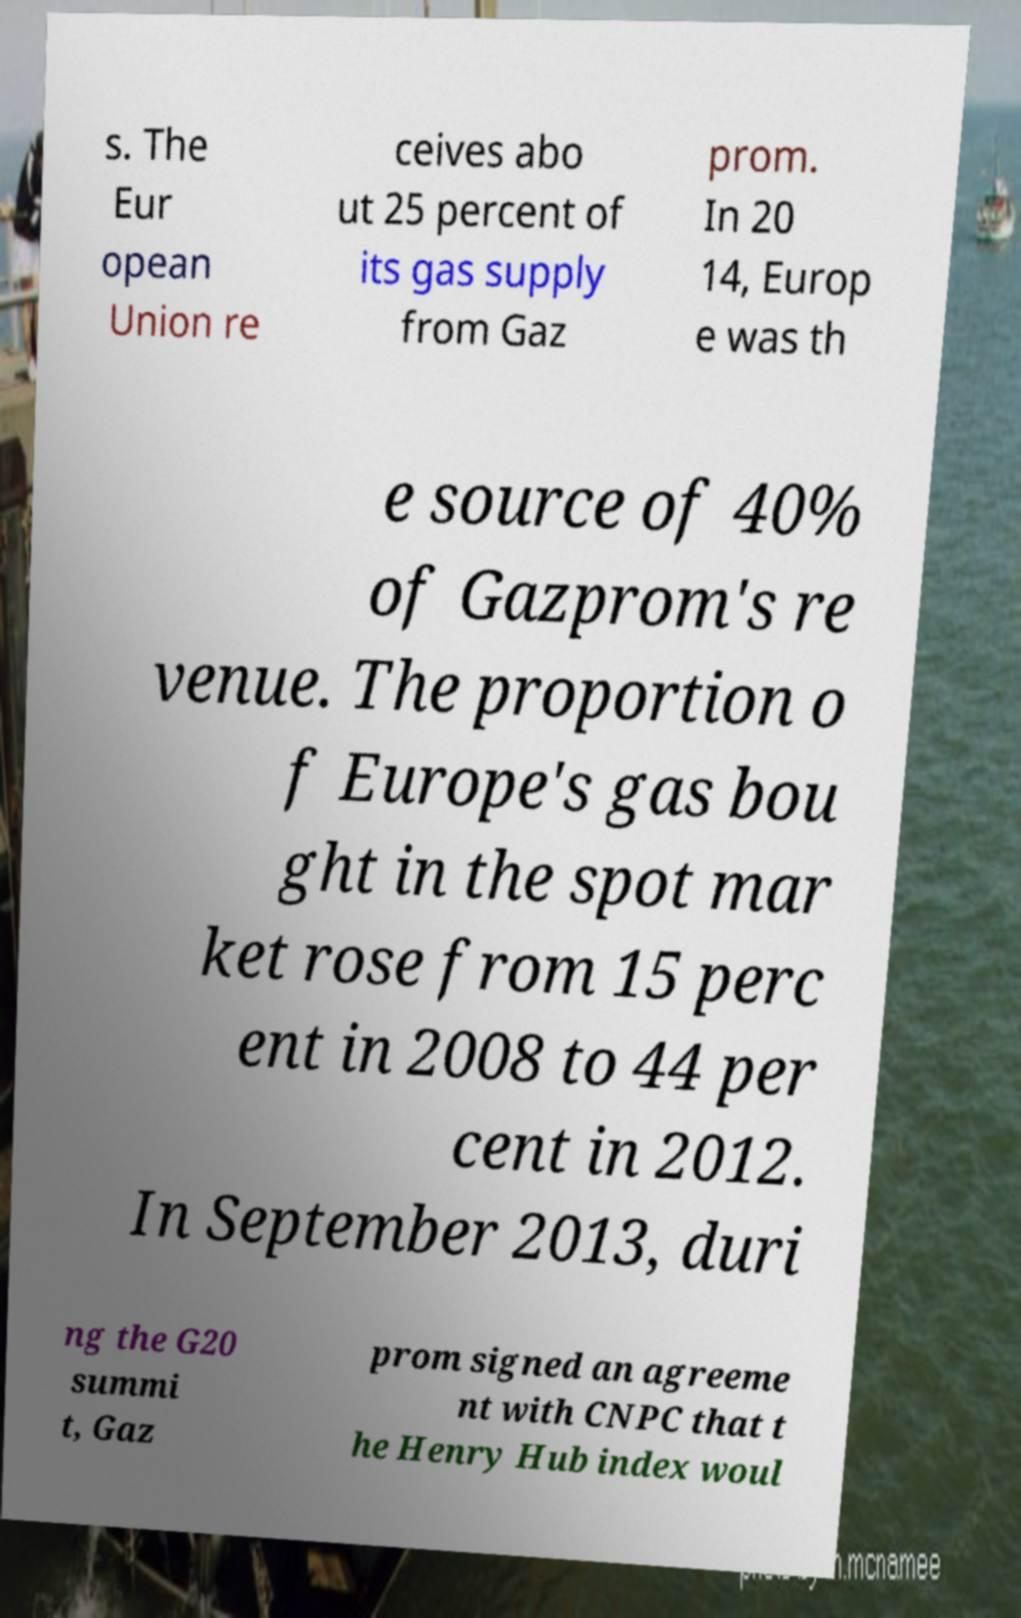There's text embedded in this image that I need extracted. Can you transcribe it verbatim? s. The Eur opean Union re ceives abo ut 25 percent of its gas supply from Gaz prom. In 20 14, Europ e was th e source of 40% of Gazprom's re venue. The proportion o f Europe's gas bou ght in the spot mar ket rose from 15 perc ent in 2008 to 44 per cent in 2012. In September 2013, duri ng the G20 summi t, Gaz prom signed an agreeme nt with CNPC that t he Henry Hub index woul 